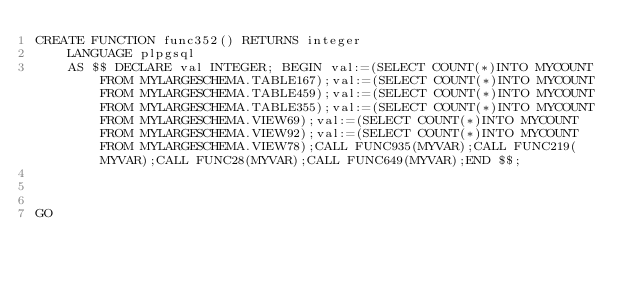Convert code to text. <code><loc_0><loc_0><loc_500><loc_500><_SQL_>CREATE FUNCTION func352() RETURNS integer
    LANGUAGE plpgsql
    AS $$ DECLARE val INTEGER; BEGIN val:=(SELECT COUNT(*)INTO MYCOUNT FROM MYLARGESCHEMA.TABLE167);val:=(SELECT COUNT(*)INTO MYCOUNT FROM MYLARGESCHEMA.TABLE459);val:=(SELECT COUNT(*)INTO MYCOUNT FROM MYLARGESCHEMA.TABLE355);val:=(SELECT COUNT(*)INTO MYCOUNT FROM MYLARGESCHEMA.VIEW69);val:=(SELECT COUNT(*)INTO MYCOUNT FROM MYLARGESCHEMA.VIEW92);val:=(SELECT COUNT(*)INTO MYCOUNT FROM MYLARGESCHEMA.VIEW78);CALL FUNC935(MYVAR);CALL FUNC219(MYVAR);CALL FUNC28(MYVAR);CALL FUNC649(MYVAR);END $$;



GO</code> 